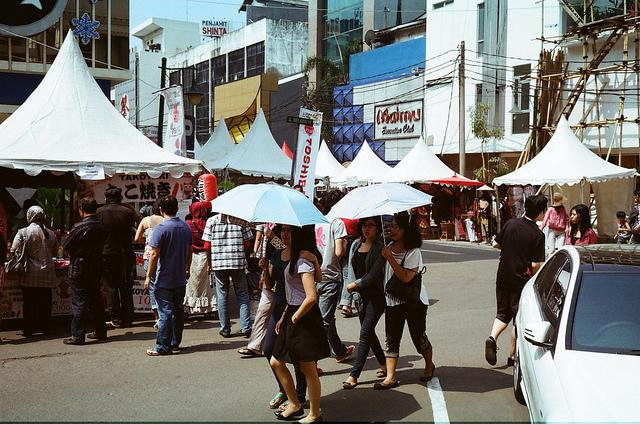Why are the people carrying umbrellas? shade 